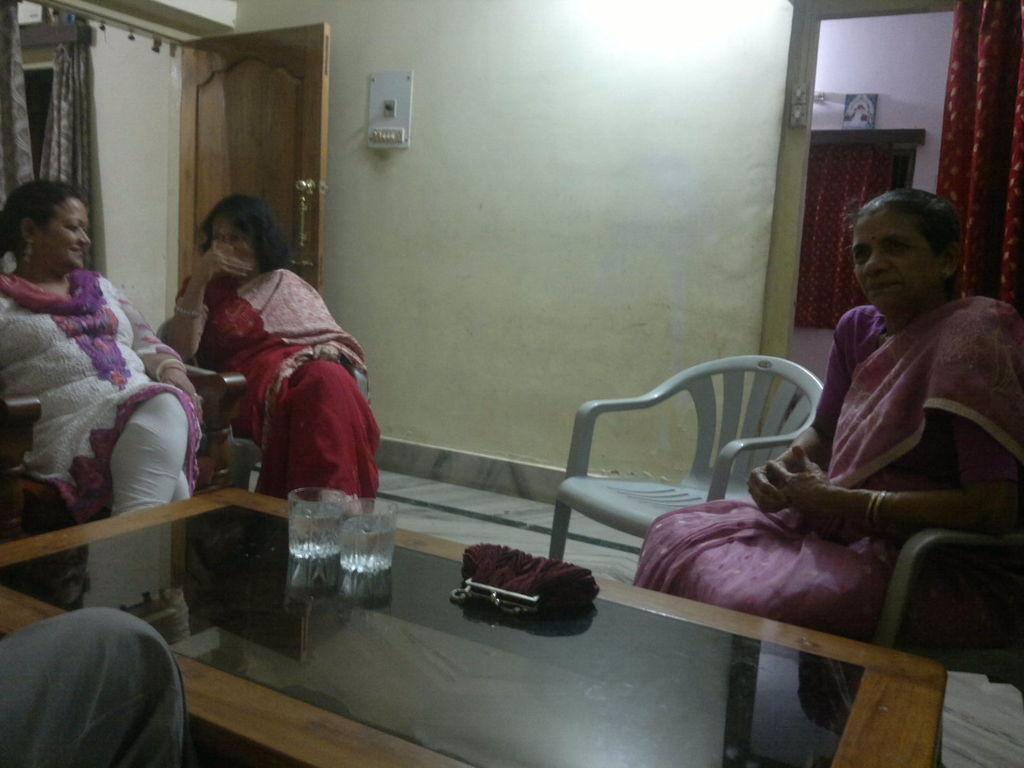Can you describe this image briefly? In the image we can see there are women who are sitting on chairs and on table there is purse and two glasses of water. 